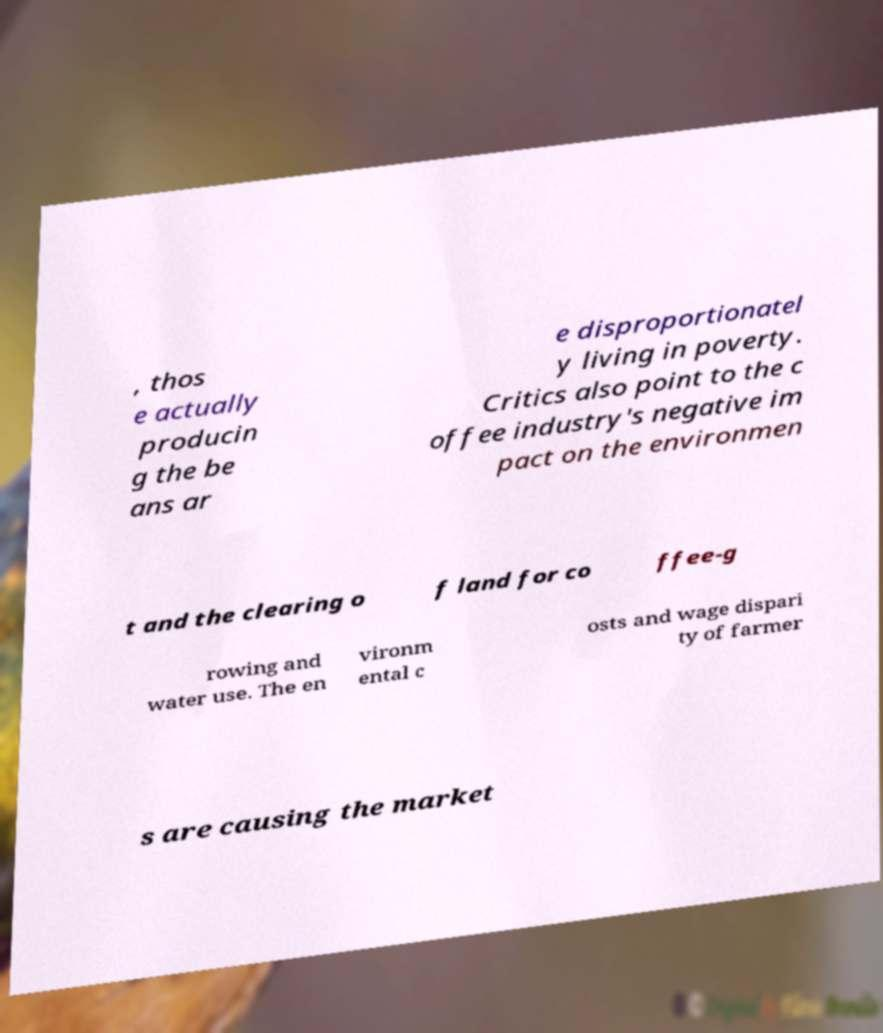Could you extract and type out the text from this image? , thos e actually producin g the be ans ar e disproportionatel y living in poverty. Critics also point to the c offee industry's negative im pact on the environmen t and the clearing o f land for co ffee-g rowing and water use. The en vironm ental c osts and wage dispari ty of farmer s are causing the market 